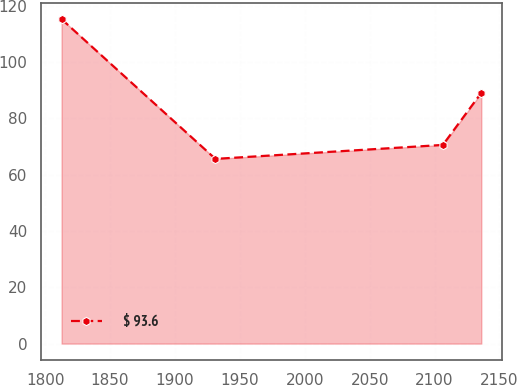Convert chart. <chart><loc_0><loc_0><loc_500><loc_500><line_chart><ecel><fcel>$ 93.6<nl><fcel>1812.67<fcel>115.24<nl><fcel>1931.18<fcel>65.61<nl><fcel>2106.39<fcel>70.57<nl><fcel>2136.03<fcel>89.09<nl></chart> 